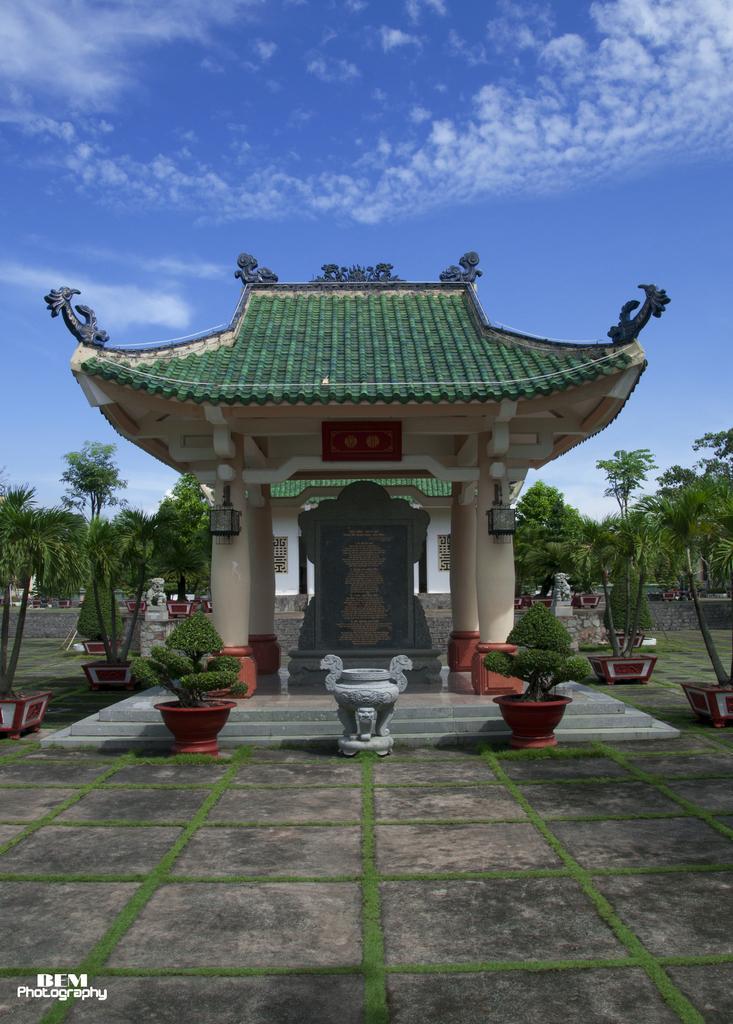Could you give a brief overview of what you see in this image? In this image I can see the black color monument and it is under the shed. To the side of the shed there are flower pots and many trees. In the background I can see the clouds and the blue sky. 